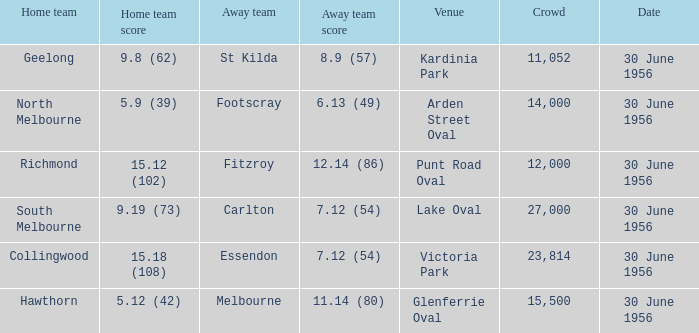What is the home team for punt road oval? Richmond. 